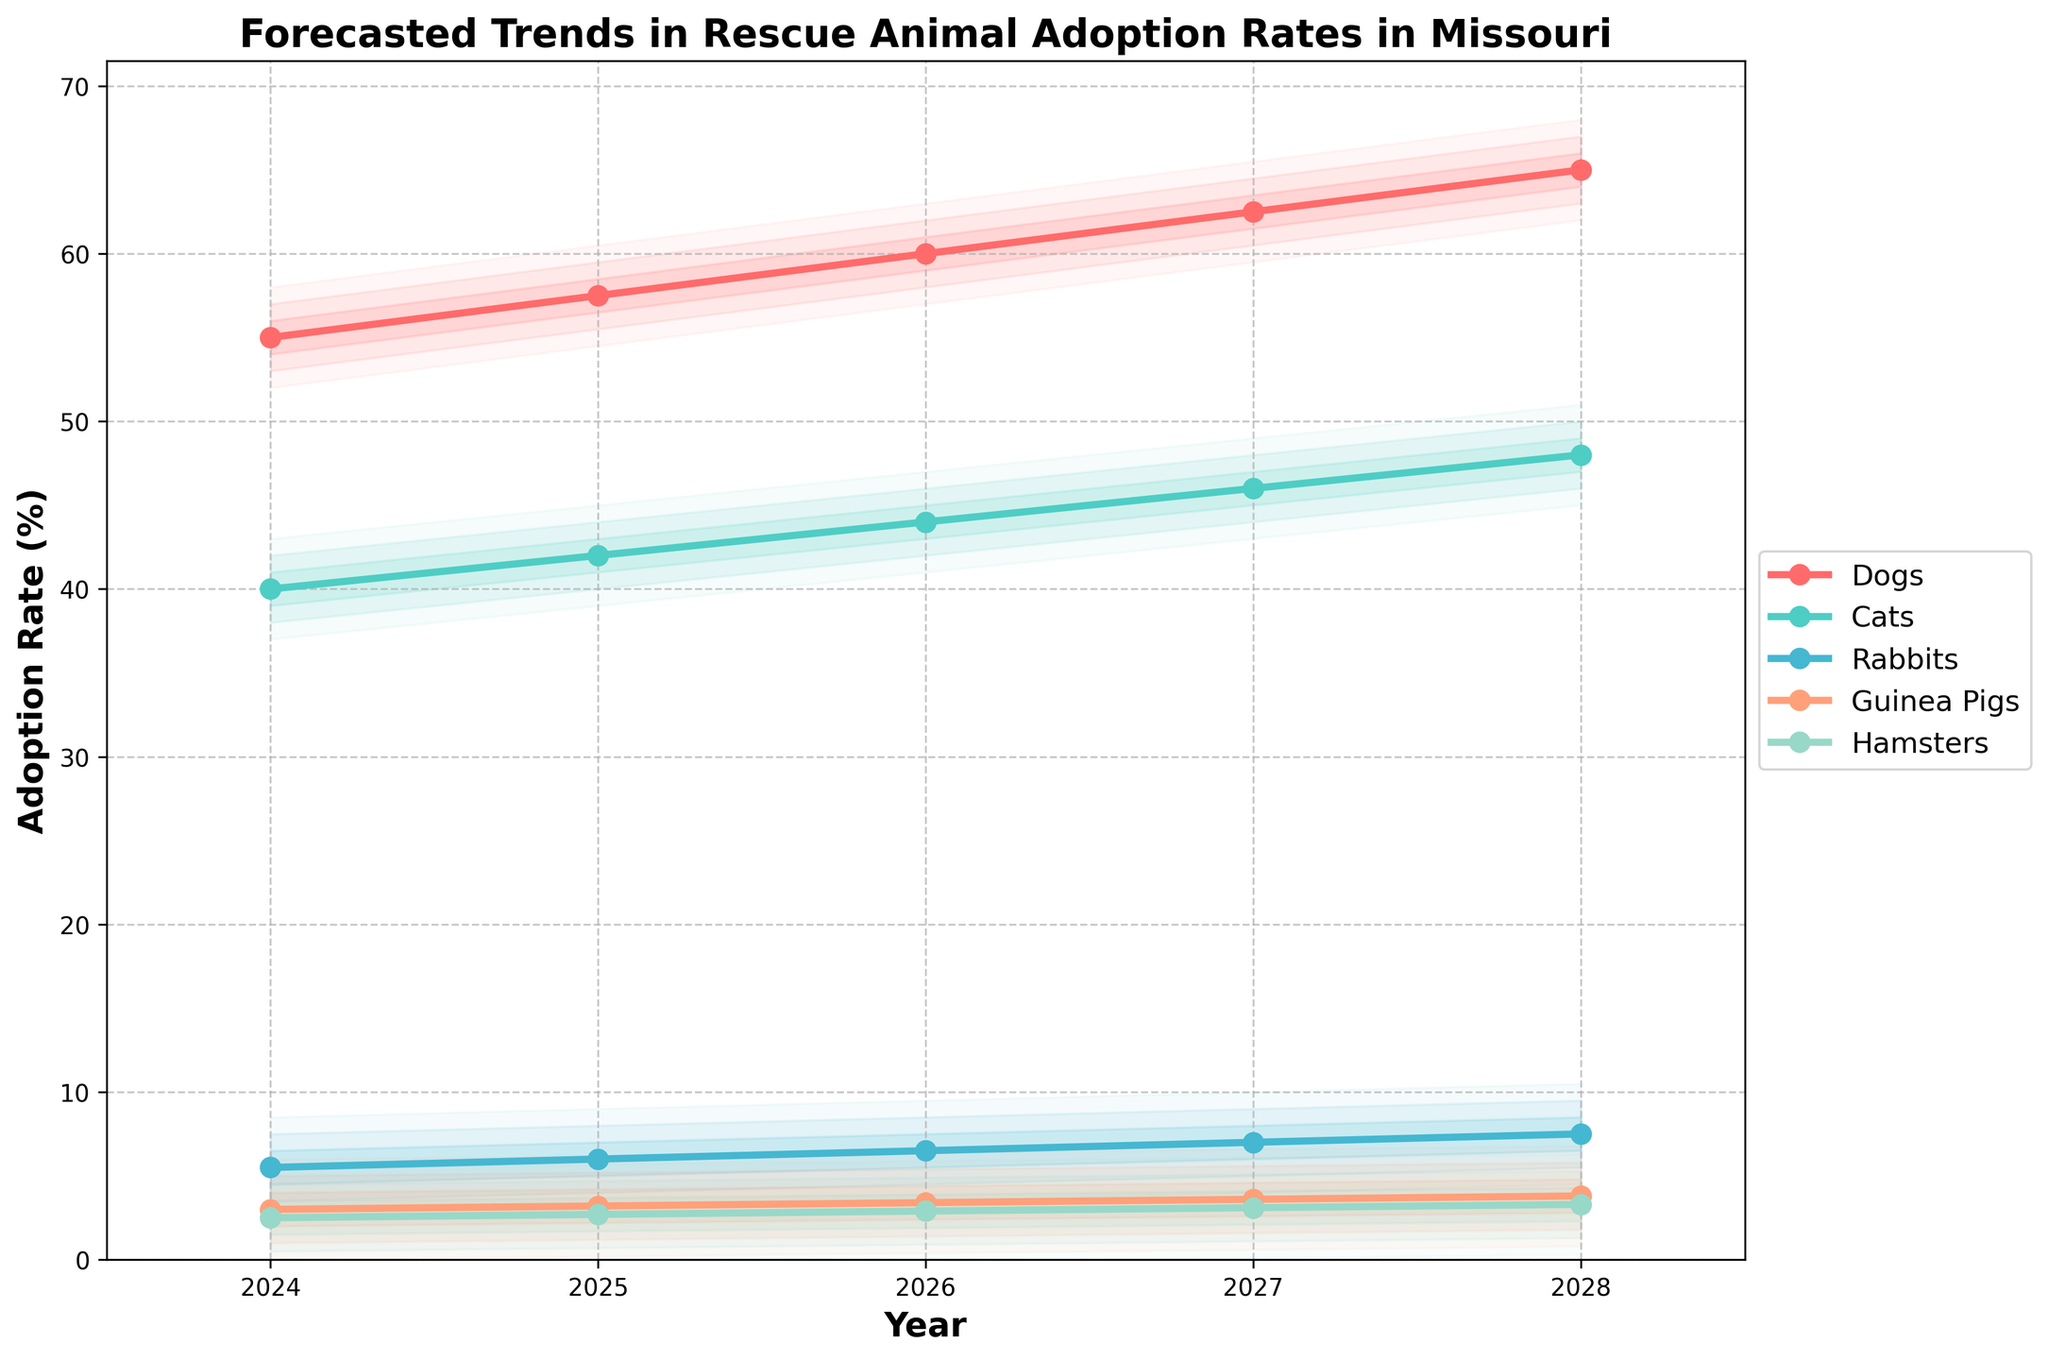What is the title of the chart? The title is usually displayed at the top of the chart. From the chart, it reads "Forecasted Trends in Rescue Animal Adoption Rates in Missouri".
Answer: Forecasted Trends in Rescue Animal Adoption Rates in Missouri Which species has the highest forecasted adoption rate for the year 2028? To determine this, we look at the rightmost data points for each species and compare their values. Dogs have the highest value of 65.0%.
Answer: Dogs What is the forecasted adoption rate for Guinea Pigs in 2026? Locate the Guinea Pigs line on the chart and find the corresponding value at the year 2026. It reads 3.4%.
Answer: 3.4% How much is the forecasted increase in adoption rates for Cats from 2024 to 2027? The forecasted rate in 2024 for Cats is 40.0% and in 2027 it is 46.0%. Subtracting the two gives us the increase: 46.0% - 40.0% = 6.0%.
Answer: 6.0% Among Dogs, Cats, and Rabbits, which species has the smallest forecasted increase in adoption rates from 2024 to 2028? Calculate the increase for each species: Dogs (65.0% - 55.0% = 10.0%), Cats (48.0% - 40.0% = 8.0%), Rabbits (7.5% - 5.5% = 2.0%). Rabbits have the smallest increase of 2.0%.
Answer: Rabbits What does the fan effect around each line represent? The fan effect shows the potential variance in the forecasted adoption rates, with each layer representing a different level of confidence (likely wider ranges further from the central line).
Answer: Potential variance in forecasted rates Compare the forecasted adoption rates for Hamsters and Rabbits in 2025. Which one is higher and by how much? In 2025, Hamsters are forecasted at 2.7% and Rabbits at 6.0%. Rabbits are higher by 6.0% - 2.7% = 3.3%.
Answer: Rabbits, 3.3% What year has the steepest increase in forecasted adoption rates for Dogs? By examining the line for Dogs, the year-to-year differences are: 2.5% increase each consecutive year. The rate of increase is constant.
Answer: Constant increase each year Which species shows the least variation in the fan effect throughout the years? Visual inspection of the fan effect indicates that Hamsters have the tightest fan bands, suggesting the least variation in forecasted adoption rates.
Answer: Hamsters 